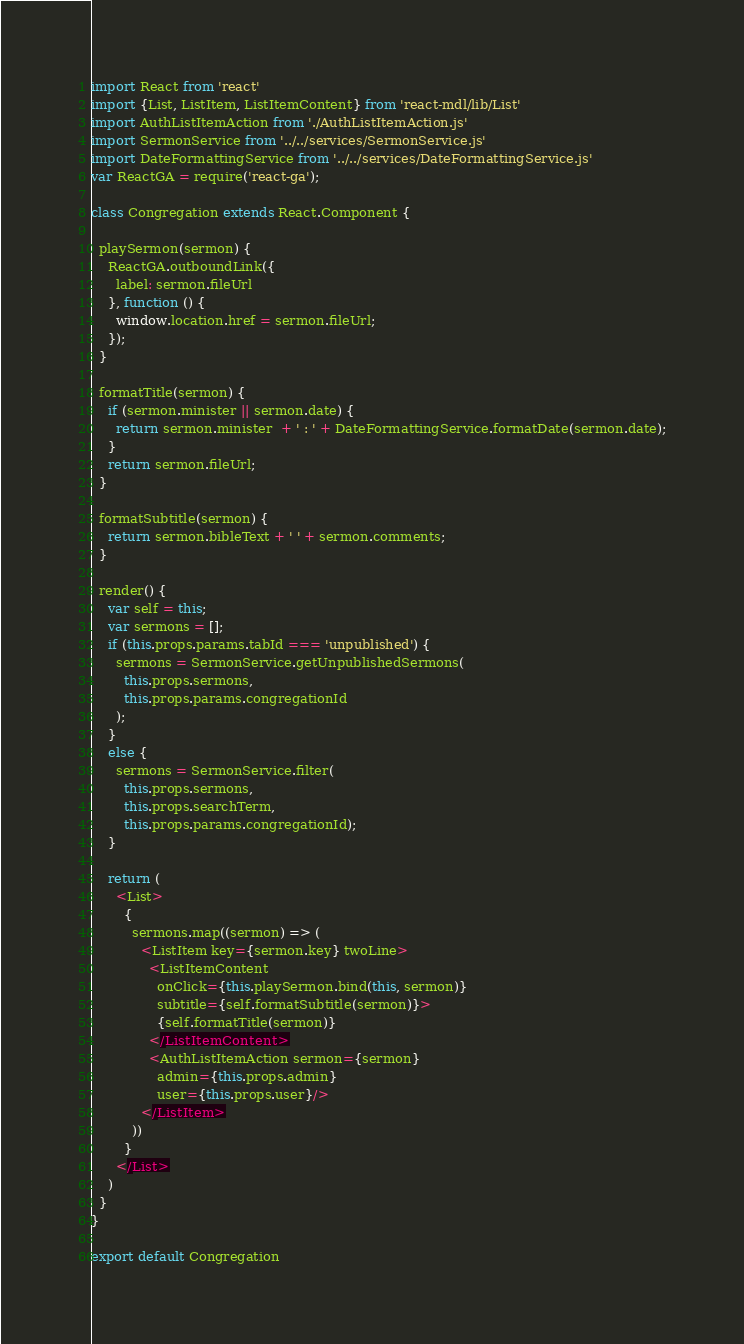Convert code to text. <code><loc_0><loc_0><loc_500><loc_500><_JavaScript_>import React from 'react'
import {List, ListItem, ListItemContent} from 'react-mdl/lib/List'
import AuthListItemAction from './AuthListItemAction.js'
import SermonService from '../../services/SermonService.js'
import DateFormattingService from '../../services/DateFormattingService.js'
var ReactGA = require('react-ga');

class Congregation extends React.Component {

  playSermon(sermon) {
    ReactGA.outboundLink({
      label: sermon.fileUrl
    }, function () {
      window.location.href = sermon.fileUrl;
    });
  }

  formatTitle(sermon) {
    if (sermon.minister || sermon.date) {
      return sermon.minister  + ' : ' + DateFormattingService.formatDate(sermon.date);
    }
    return sermon.fileUrl;
  }

  formatSubtitle(sermon) {
    return sermon.bibleText + ' ' + sermon.comments;
  }

  render() {
    var self = this;
    var sermons = [];
    if (this.props.params.tabId === 'unpublished') {
      sermons = SermonService.getUnpublishedSermons(
        this.props.sermons,
        this.props.params.congregationId
      );
    }
    else {
      sermons = SermonService.filter(
        this.props.sermons,
        this.props.searchTerm,
        this.props.params.congregationId);
    }

    return (
      <List>
        {
          sermons.map((sermon) => (
            <ListItem key={sermon.key} twoLine>
              <ListItemContent
                onClick={this.playSermon.bind(this, sermon)}
                subtitle={self.formatSubtitle(sermon)}>
                {self.formatTitle(sermon)}
              </ListItemContent>
              <AuthListItemAction sermon={sermon}
                admin={this.props.admin}
                user={this.props.user}/>
            </ListItem>
          ))
        }
      </List>
    )
  }
}

export default Congregation
</code> 